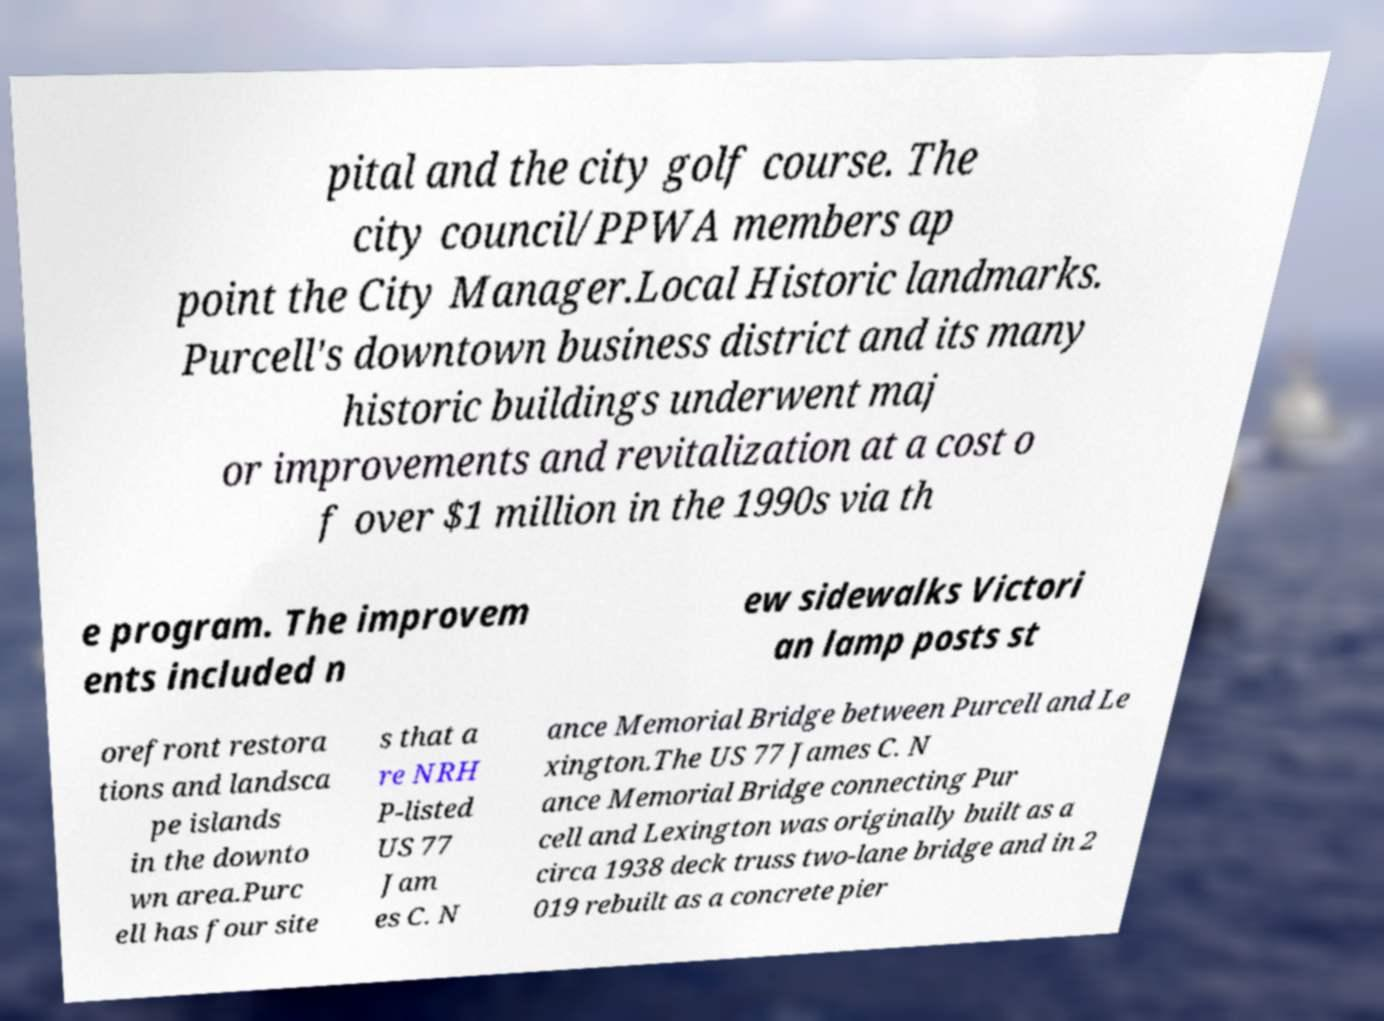Please identify and transcribe the text found in this image. pital and the city golf course. The city council/PPWA members ap point the City Manager.Local Historic landmarks. Purcell's downtown business district and its many historic buildings underwent maj or improvements and revitalization at a cost o f over $1 million in the 1990s via th e program. The improvem ents included n ew sidewalks Victori an lamp posts st orefront restora tions and landsca pe islands in the downto wn area.Purc ell has four site s that a re NRH P-listed US 77 Jam es C. N ance Memorial Bridge between Purcell and Le xington.The US 77 James C. N ance Memorial Bridge connecting Pur cell and Lexington was originally built as a circa 1938 deck truss two-lane bridge and in 2 019 rebuilt as a concrete pier 